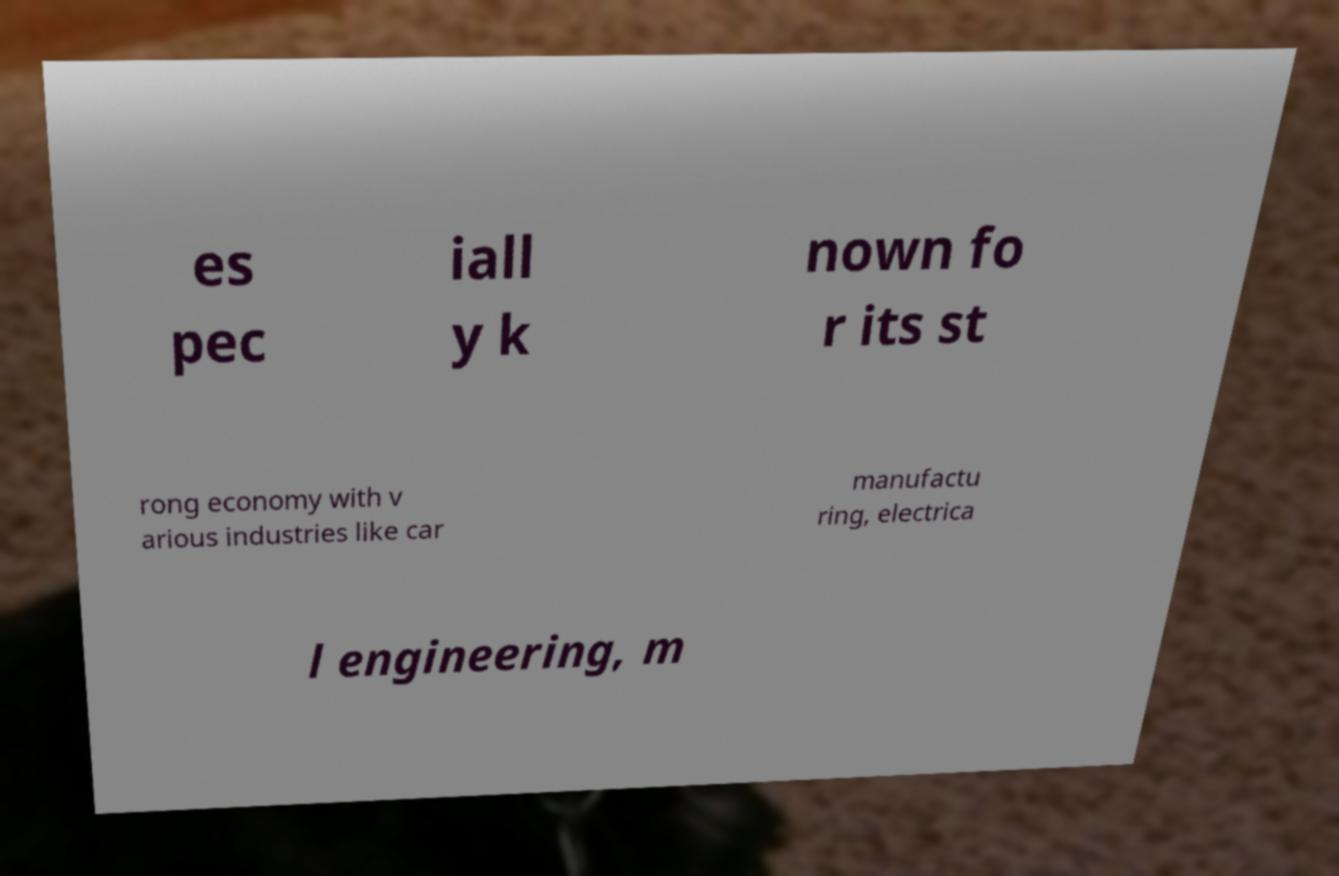Can you accurately transcribe the text from the provided image for me? es pec iall y k nown fo r its st rong economy with v arious industries like car manufactu ring, electrica l engineering, m 